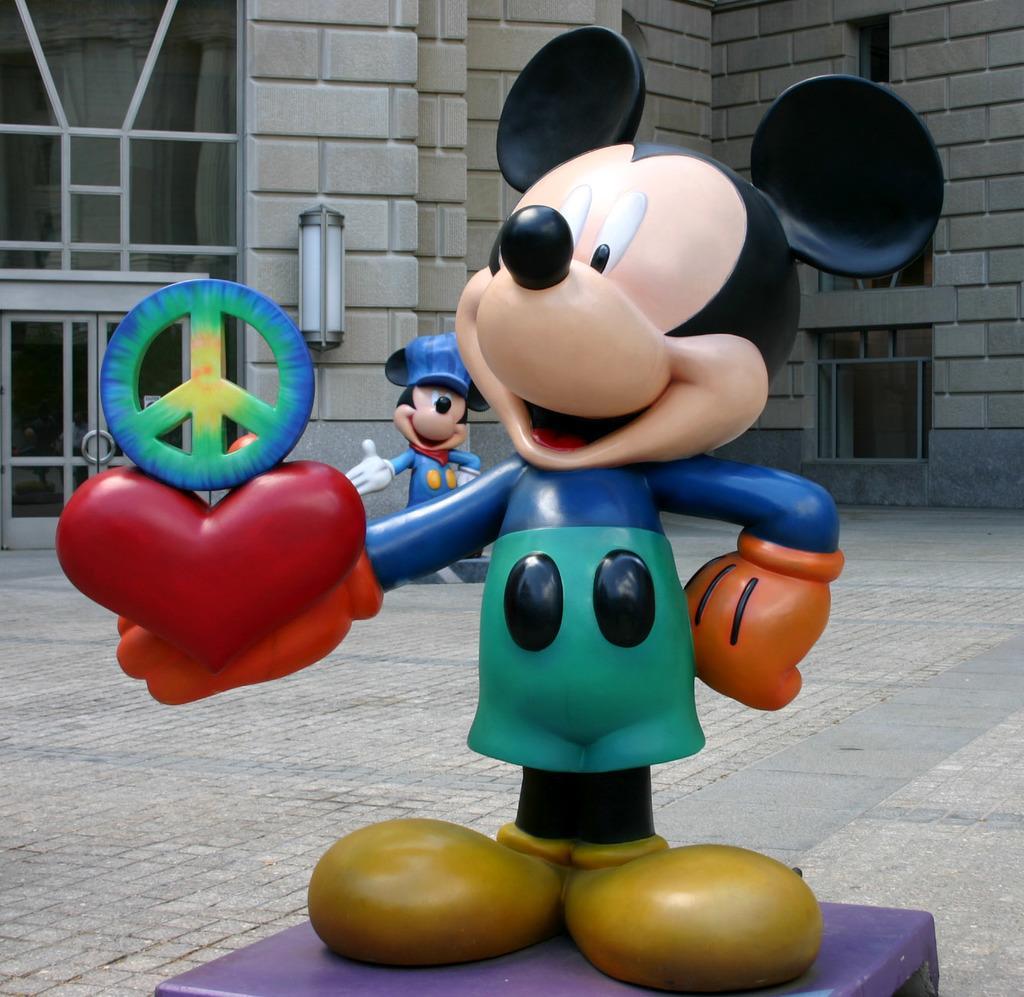In one or two sentences, can you explain what this image depicts? This picture is clicked outside. In the foreground we can see the statue of a mickey mouse holding some objects and standing and we can see the building and we can see the door, windows and the wall of the building and we can see an object attached to the wall of a building and we can see another statue of a mickey mouse in the background. 